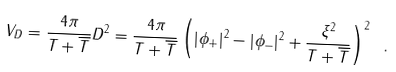<formula> <loc_0><loc_0><loc_500><loc_500>V _ { D } = \frac { 4 \pi } { T + \overline { T } } D ^ { 2 } = \frac { 4 \pi } { T + \overline { T } } \left ( | \phi _ { + } | ^ { 2 } - | \phi _ { - } | ^ { 2 } + \frac { \xi ^ { 2 } } { T + \overline { T } } \right ) ^ { 2 } \ .</formula> 